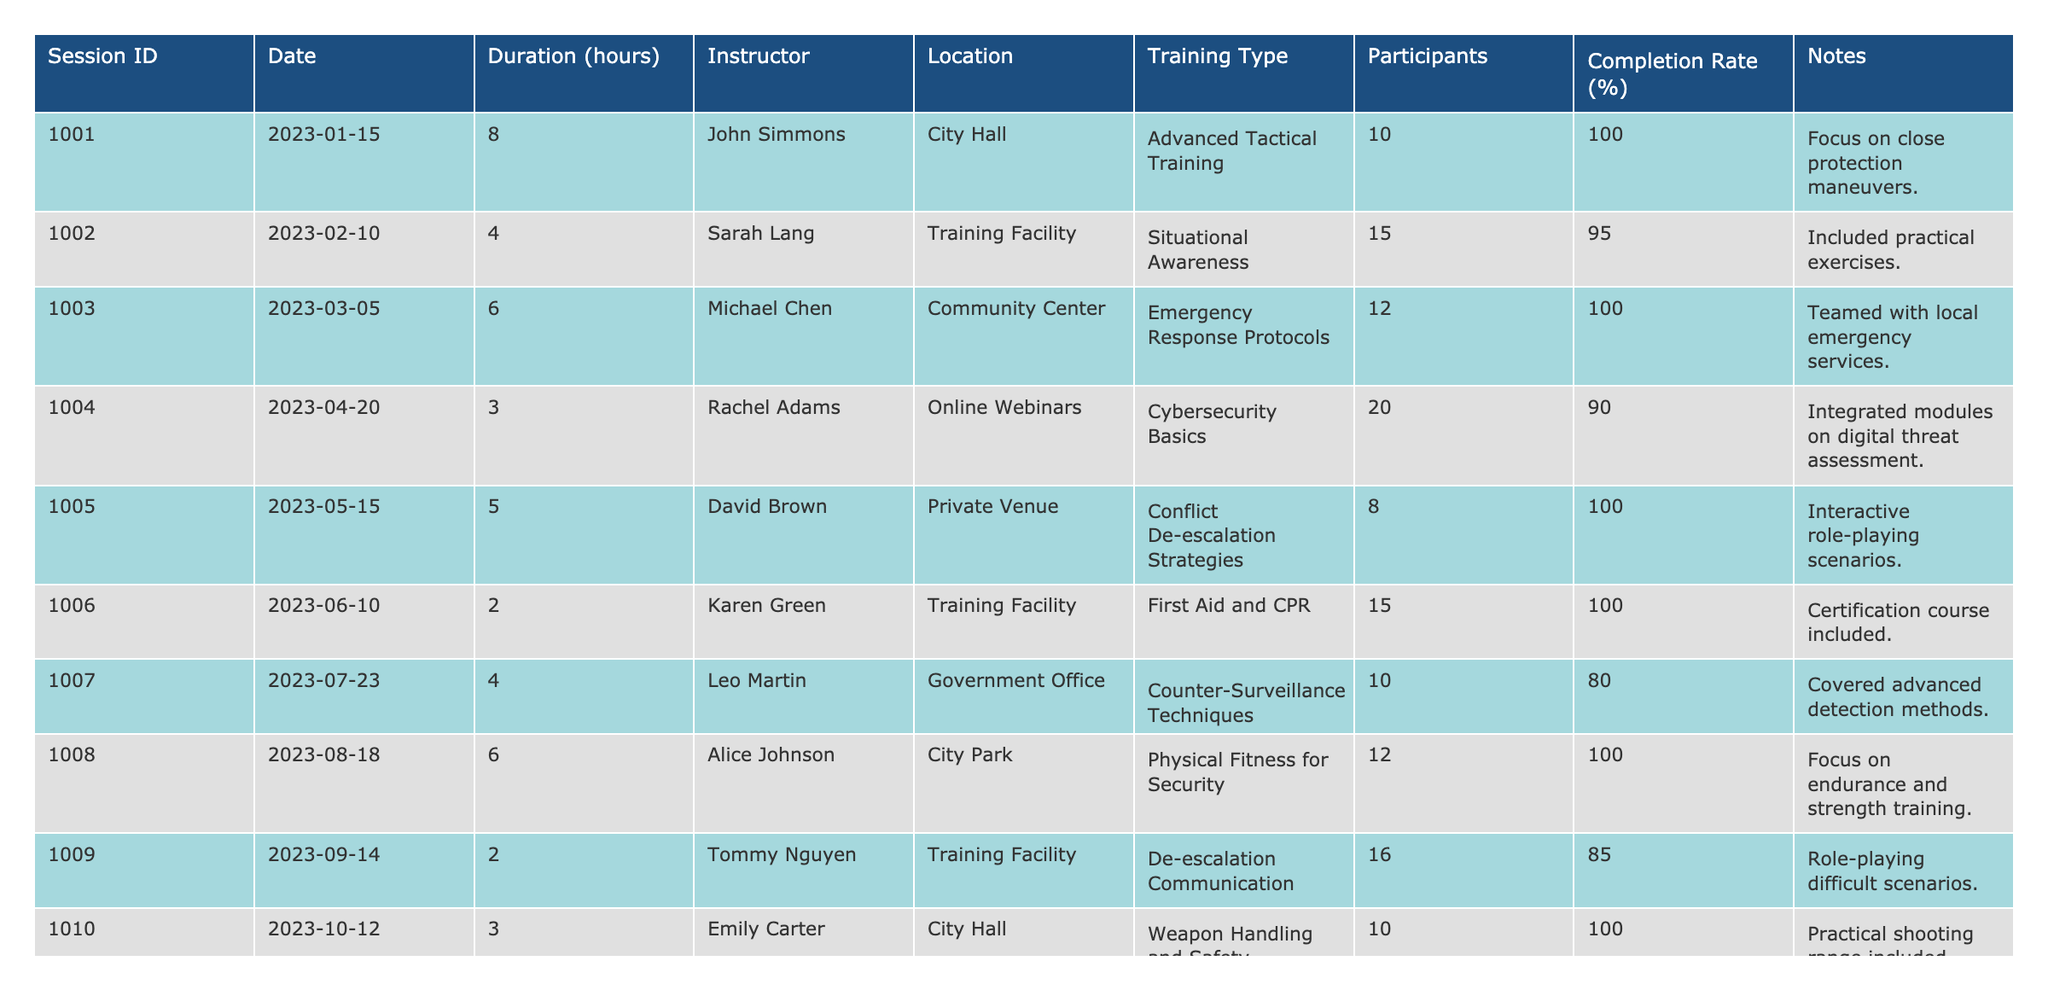What is the total number of hours of training completed by the team in 2023? To find the total hours, sum the durations of all sessions listed in the table: 8 + 4 + 6 + 3 + 5 + 2 + 4 + 6 + 2 + 3 + 5 + 7 = 60 hours
Answer: 60 hours Which training session had the highest completion rate? The highest completion rate is found by reviewing the "Completion Rate (%)" column. The sessions with rates of 100% are: Advanced Tactical Training, Conflict De-escalation Strategies, First Aid and CPR, Physical Fitness for Security, Weapon Handling and Safety, and Personal Safety Awareness. All these sessions tie for the highest rate
Answer: Advanced Tactical Training, Conflict De-escalation Strategies, First Aid and CPR, Physical Fitness for Security, Weapon Handling and Safety, and Personal Safety Awareness What was the average duration of the training sessions? Sum the duration of all sessions (60 hours), then divide by the number of sessions (12). Thus, 60 / 12 = 5 hours
Answer: 5 hours Did any training session focus on cybersecurity? The table lists "Cybersecurity Basics" under training type in session 1004, confirming the focus on cybersecurity
Answer: Yes Which instructor conducted the most training sessions? Count the occurrences of each instructor in the "Instructor" column. The counts show: John Simmons (1), Sarah Lang (1), Michael Chen (1), Rachel Adams (1), David Brown (1), Karen Green (1), Leo Martin (1), Alice Johnson (1), Tommy Nguyen (1), Emily Carter (1), George West (1), and Nina Patel (1). Each instructor has conducted exactly one session
Answer: No instructor conducted more than one session What was the longest training session by duration? Review the "Duration (hours)" column to find the maximum value. The longest session has 8 hours, which is the Advanced Tactical Training session (ID 1001)
Answer: Advanced Tactical Training (8 hours) How many sessions had a completion rate lower than 90%? Identify the sessions with rates below 90%: Counter-Surveillance Techniques (80%) and De-escalation Communication (85%). There are 2 such sessions
Answer: 2 sessions What was the total number of participants across all training sessions? Sum the number of participants for each session: 10 + 15 + 12 + 20 + 8 + 15 + 10 + 12 + 16 + 10 + 14 + 18 =  159
Answer: 159 participants Which training type had the most sessions conducted? Count the frequency of each training type: Advanced Tactical Training (1), Situational Awareness (1), Emergency Response Protocols (1), Cybersecurity Basics (1), Conflict De-escalation Strategies (1), First Aid and CPR (1), Counter-Surveillance Techniques (1), Physical Fitness for Security (1), De-escalation Communication (1), Weapon Handling and Safety (1), Surveillance and Observation Skills (1), Personal Safety Awareness (1). There is no repetition, so no type had more than one session
Answer: No training type had multiple sessions 